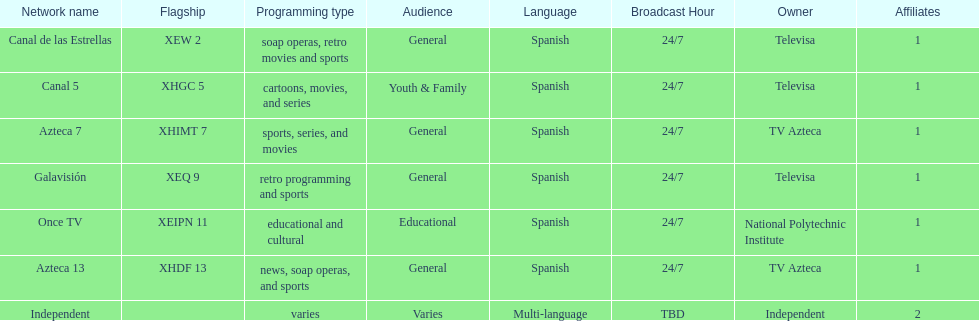Who are the owners of the stations listed here? Televisa, Televisa, TV Azteca, Televisa, National Polytechnic Institute, TV Azteca, Independent. What is the one station owned by national polytechnic institute? Once TV. 